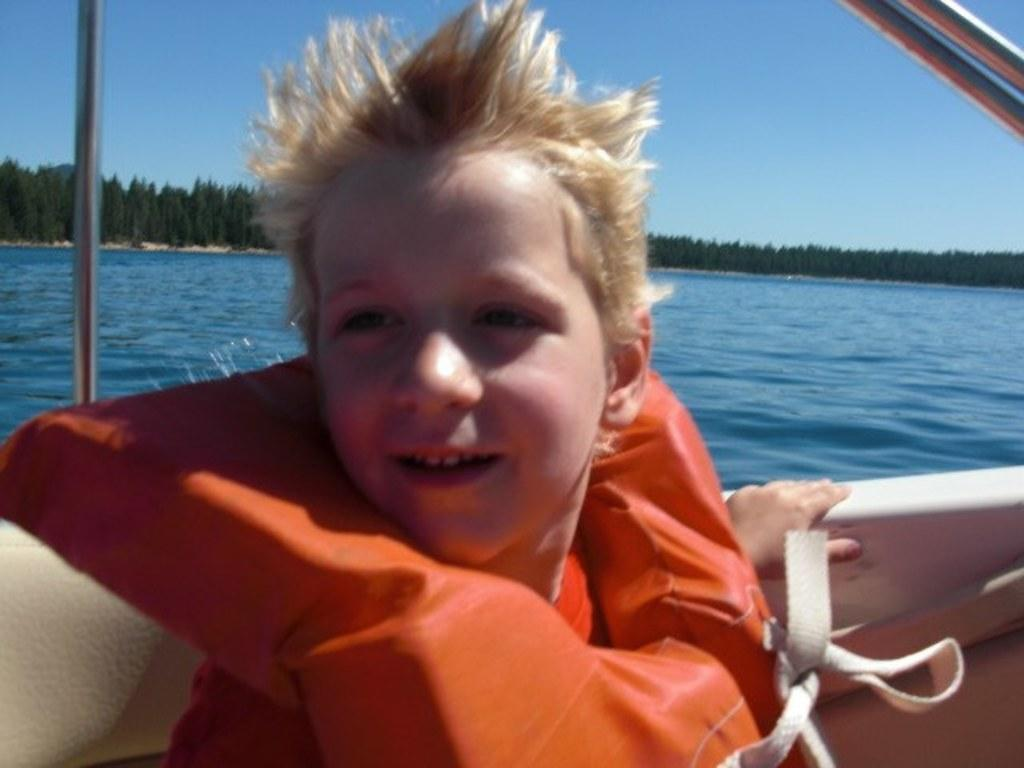Who is in the image? There is a boy in the image. What is the boy wearing? The boy is wearing an orange life jacket. Where is the boy sitting? The boy is sitting in a boat. What is the boat's location in relation to the water? The boat is on the surface of the water. What can be seen in the background of the image? There are trees and the sky visible in the background of the image. What type of mark does the boy leave on the water as he takes his journey? There is no mention of the boy taking a journey in the image, and no marks are visible on the water. 